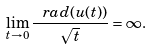<formula> <loc_0><loc_0><loc_500><loc_500>\lim _ { t \to 0 } \frac { \ r a d ( u ( t ) ) } { \sqrt { t } } = \infty .</formula> 